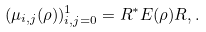Convert formula to latex. <formula><loc_0><loc_0><loc_500><loc_500>( \mu _ { i , j } ( \rho ) ) _ { i , j = 0 } ^ { 1 } = R ^ { * } E ( \rho ) R , .</formula> 